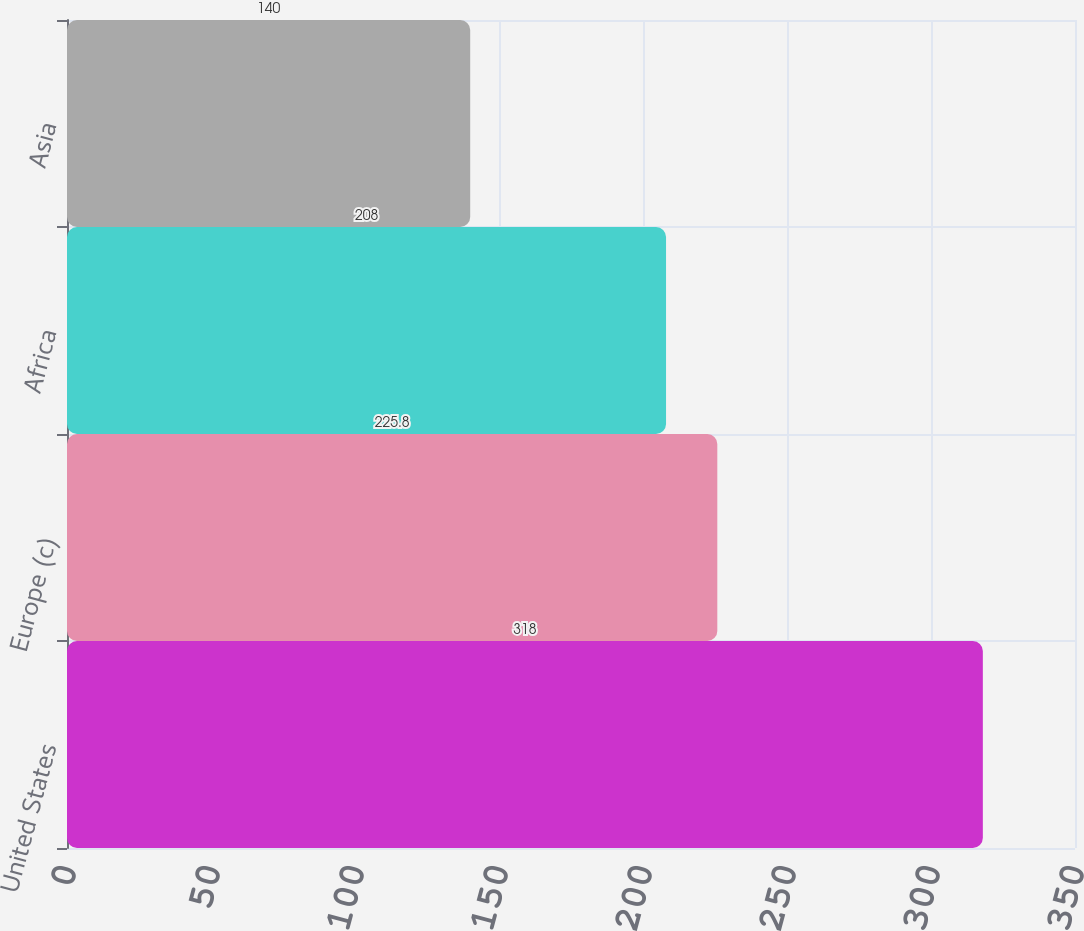Convert chart to OTSL. <chart><loc_0><loc_0><loc_500><loc_500><bar_chart><fcel>United States<fcel>Europe (c)<fcel>Africa<fcel>Asia<nl><fcel>318<fcel>225.8<fcel>208<fcel>140<nl></chart> 